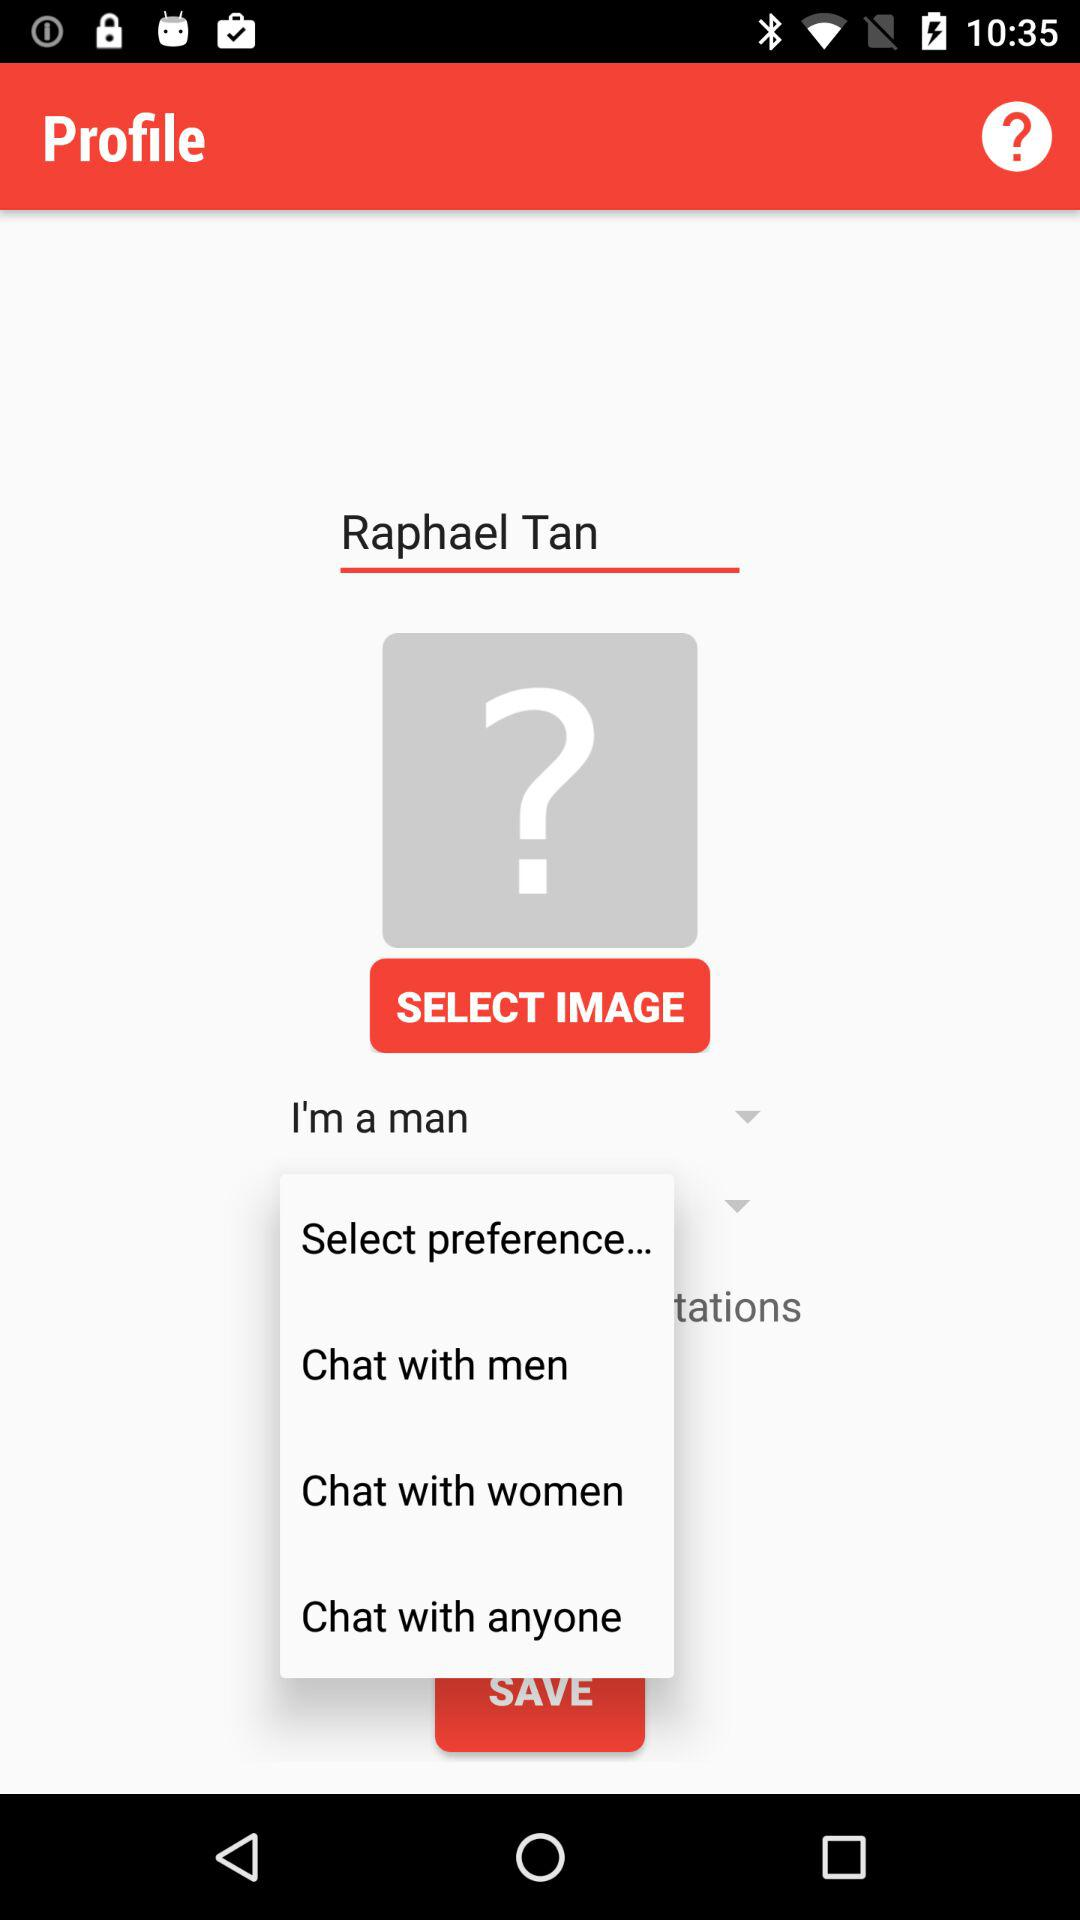How many options are there to select the gender of users you want to chat with?
Answer the question using a single word or phrase. 3 